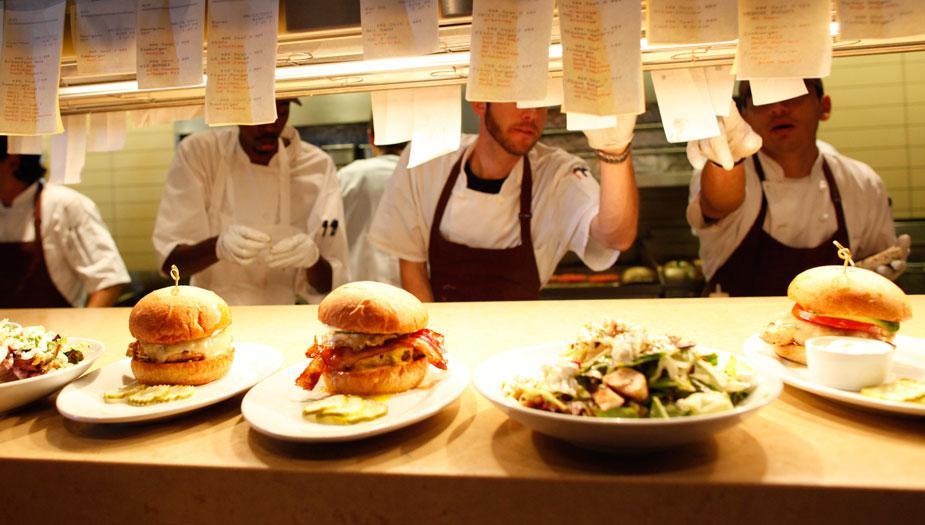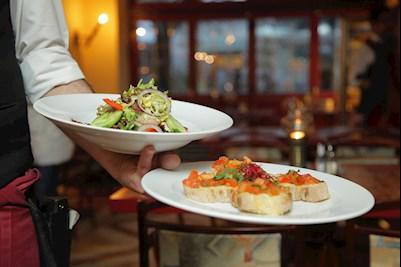The first image is the image on the left, the second image is the image on the right. Examine the images to the left and right. Is the description "In at one image there is a server holding at least two white plates." accurate? Answer yes or no. Yes. The first image is the image on the left, the second image is the image on the right. Assess this claim about the two images: "The foreground of an image features someone with an extended arm holding up multiple white plates filled with food.". Correct or not? Answer yes or no. Yes. 